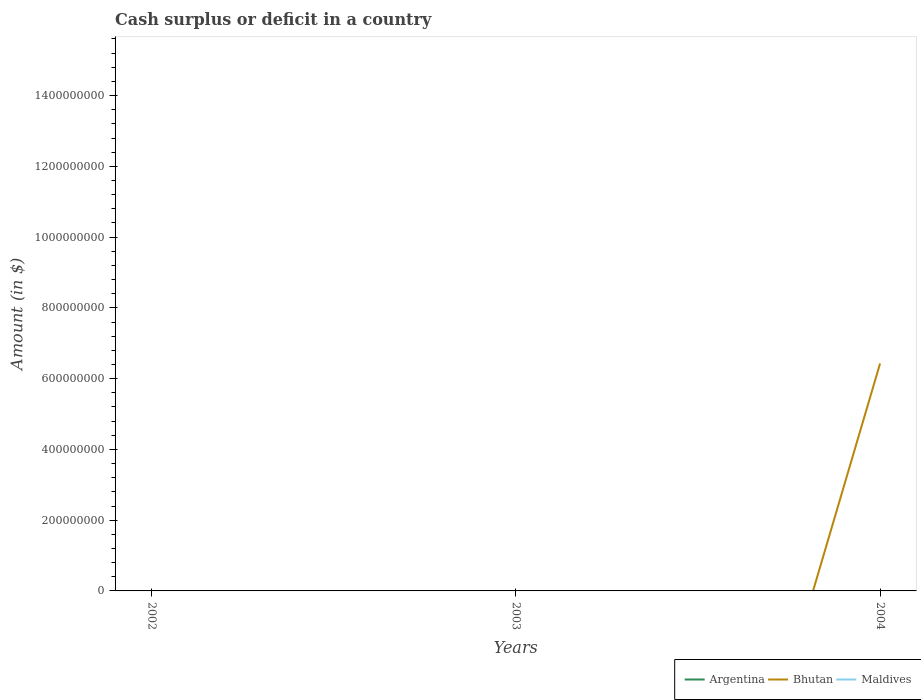Across all years, what is the maximum amount of cash surplus or deficit in Maldives?
Your response must be concise. 0. What is the difference between the highest and the second highest amount of cash surplus or deficit in Bhutan?
Your response must be concise. 6.43e+08. How many lines are there?
Your response must be concise. 1. How many years are there in the graph?
Keep it short and to the point. 3. What is the difference between two consecutive major ticks on the Y-axis?
Ensure brevity in your answer.  2.00e+08. Does the graph contain any zero values?
Provide a succinct answer. Yes. Does the graph contain grids?
Make the answer very short. No. How many legend labels are there?
Provide a short and direct response. 3. What is the title of the graph?
Your response must be concise. Cash surplus or deficit in a country. What is the label or title of the X-axis?
Your answer should be very brief. Years. What is the label or title of the Y-axis?
Your answer should be very brief. Amount (in $). What is the Amount (in $) of Argentina in 2002?
Keep it short and to the point. 0. What is the Amount (in $) of Maldives in 2002?
Keep it short and to the point. 0. What is the Amount (in $) in Bhutan in 2003?
Give a very brief answer. 0. What is the Amount (in $) in Maldives in 2003?
Provide a succinct answer. 0. What is the Amount (in $) in Argentina in 2004?
Give a very brief answer. 0. What is the Amount (in $) of Bhutan in 2004?
Keep it short and to the point. 6.43e+08. What is the Amount (in $) of Maldives in 2004?
Give a very brief answer. 0. Across all years, what is the maximum Amount (in $) of Bhutan?
Offer a very short reply. 6.43e+08. What is the total Amount (in $) of Argentina in the graph?
Offer a terse response. 0. What is the total Amount (in $) in Bhutan in the graph?
Make the answer very short. 6.43e+08. What is the total Amount (in $) in Maldives in the graph?
Provide a succinct answer. 0. What is the average Amount (in $) in Argentina per year?
Your answer should be very brief. 0. What is the average Amount (in $) in Bhutan per year?
Your answer should be very brief. 2.14e+08. What is the difference between the highest and the lowest Amount (in $) of Bhutan?
Give a very brief answer. 6.43e+08. 